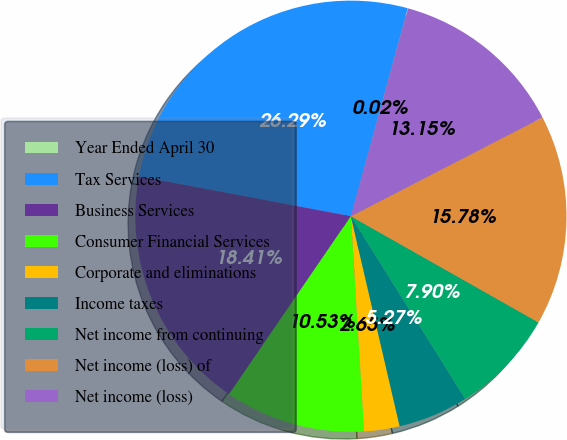Convert chart to OTSL. <chart><loc_0><loc_0><loc_500><loc_500><pie_chart><fcel>Year Ended April 30<fcel>Tax Services<fcel>Business Services<fcel>Consumer Financial Services<fcel>Corporate and eliminations<fcel>Income taxes<fcel>Net income from continuing<fcel>Net income (loss) of<fcel>Net income (loss)<nl><fcel>0.02%<fcel>26.29%<fcel>18.41%<fcel>10.53%<fcel>2.65%<fcel>5.27%<fcel>7.9%<fcel>15.78%<fcel>13.15%<nl></chart> 